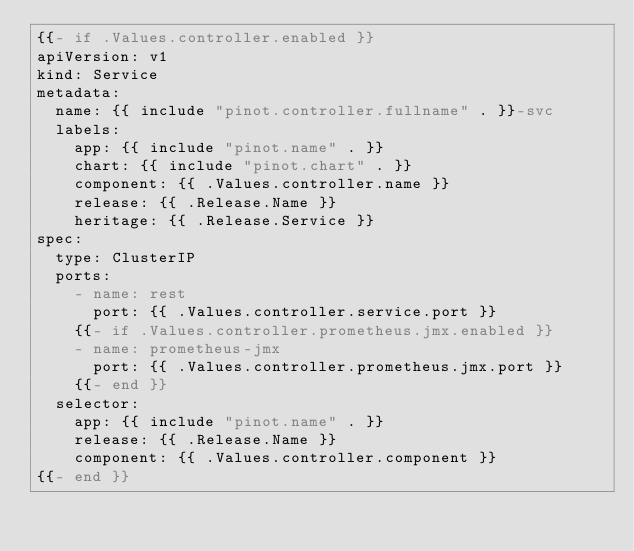Convert code to text. <code><loc_0><loc_0><loc_500><loc_500><_YAML_>{{- if .Values.controller.enabled }}
apiVersion: v1
kind: Service
metadata:
  name: {{ include "pinot.controller.fullname" . }}-svc
  labels:
    app: {{ include "pinot.name" . }}
    chart: {{ include "pinot.chart" . }}
    component: {{ .Values.controller.name }}
    release: {{ .Release.Name }}
    heritage: {{ .Release.Service }}
spec:
  type: ClusterIP
  ports:
    - name: rest
      port: {{ .Values.controller.service.port }}
    {{- if .Values.controller.prometheus.jmx.enabled }}
    - name: prometheus-jmx
      port: {{ .Values.controller.prometheus.jmx.port }}
    {{- end }}
  selector:
    app: {{ include "pinot.name" . }}
    release: {{ .Release.Name }}
    component: {{ .Values.controller.component }}
{{- end }}
</code> 